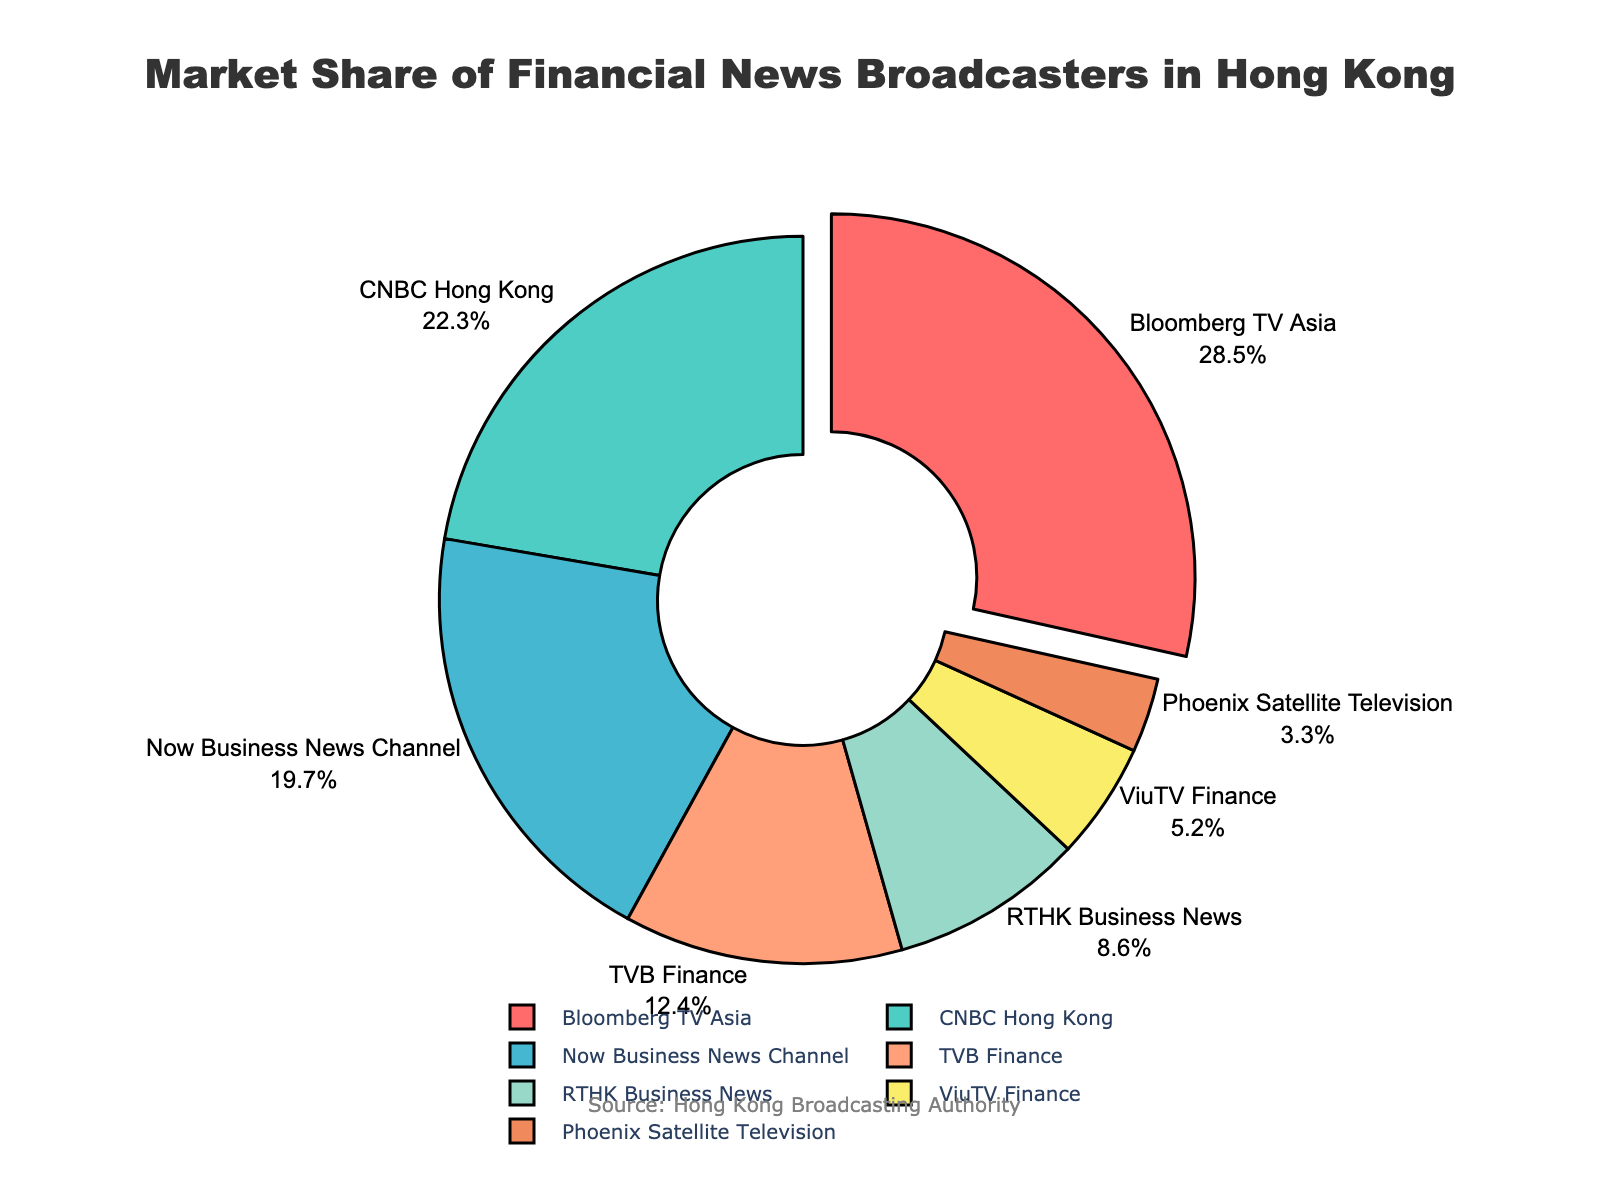What is the market share of Bloomberg TV Asia? The pie chart clearly shows that Bloomberg TV Asia has a market share of 28.5%. This information is found by looking at the label and percentage next to the corresponding section of the pie chart.
Answer: 28.5% Which financial news broadcaster has the second-largest market share? By examining the slices of the pie chart and their respective labels, we can see that CNBC Hong Kong holds the second-largest market share with 22.3%.
Answer: CNBC Hong Kong How much more market share does Bloomberg TV Asia have compared to TVB Finance? Bloomberg TV Asia has a market share of 28.5%, whereas TVB Finance has 12.4%. The difference can be calculated as 28.5% - 12.4% = 16.1%.
Answer: 16.1% Which financial news broadcasters have a market share less than 10%? By looking at the pie chart, we can identify that the broadcasters with market shares less than 10% are RTHK Business News, ViuTV Finance, and Phoenix Satellite Television, with 8.6%, 5.2%, and 3.3% respectively.
Answer: RTHK Business News, ViuTV Finance, Phoenix Satellite Television What is the combined market share of Now Business News Channel and TVB Finance? Now Business News Channel has a market share of 19.7%, and TVB Finance has 12.4%. Adding these two values together yields 19.7% + 12.4% = 32.1%.
Answer: 32.1% Which section of the pie chart has been slightly pulled out? The section for Bloomberg TV Asia has been slightly pulled out from the pie chart, which helps to visually highlight that it has the largest market share at 28.5%.
Answer: Bloomberg TV Asia How does the market share of ViuTV Finance compare to that of RTHK Business News? The pie chart shows that ViuTV Finance has a market share of 5.2%, while RTHK Business News has a market share of 8.6%. Therefore, RTHK Business News has a larger market share.
Answer: RTHK Business News has a larger market share If we rank the financial news broadcasters by market share, which would come in fourth place? By examining the market shares in descending order, Bloomberg TV Asia comes first, followed by CNBC Hong Kong, Now Business News Channel, and then TVB Finance with 12.4%.
Answer: TVB Finance What is the smallest market share held by any financial news broadcaster? The smallest market share depicted in the pie chart is held by Phoenix Satellite Television, which is 3.3%.
Answer: Phoenix Satellite Television 